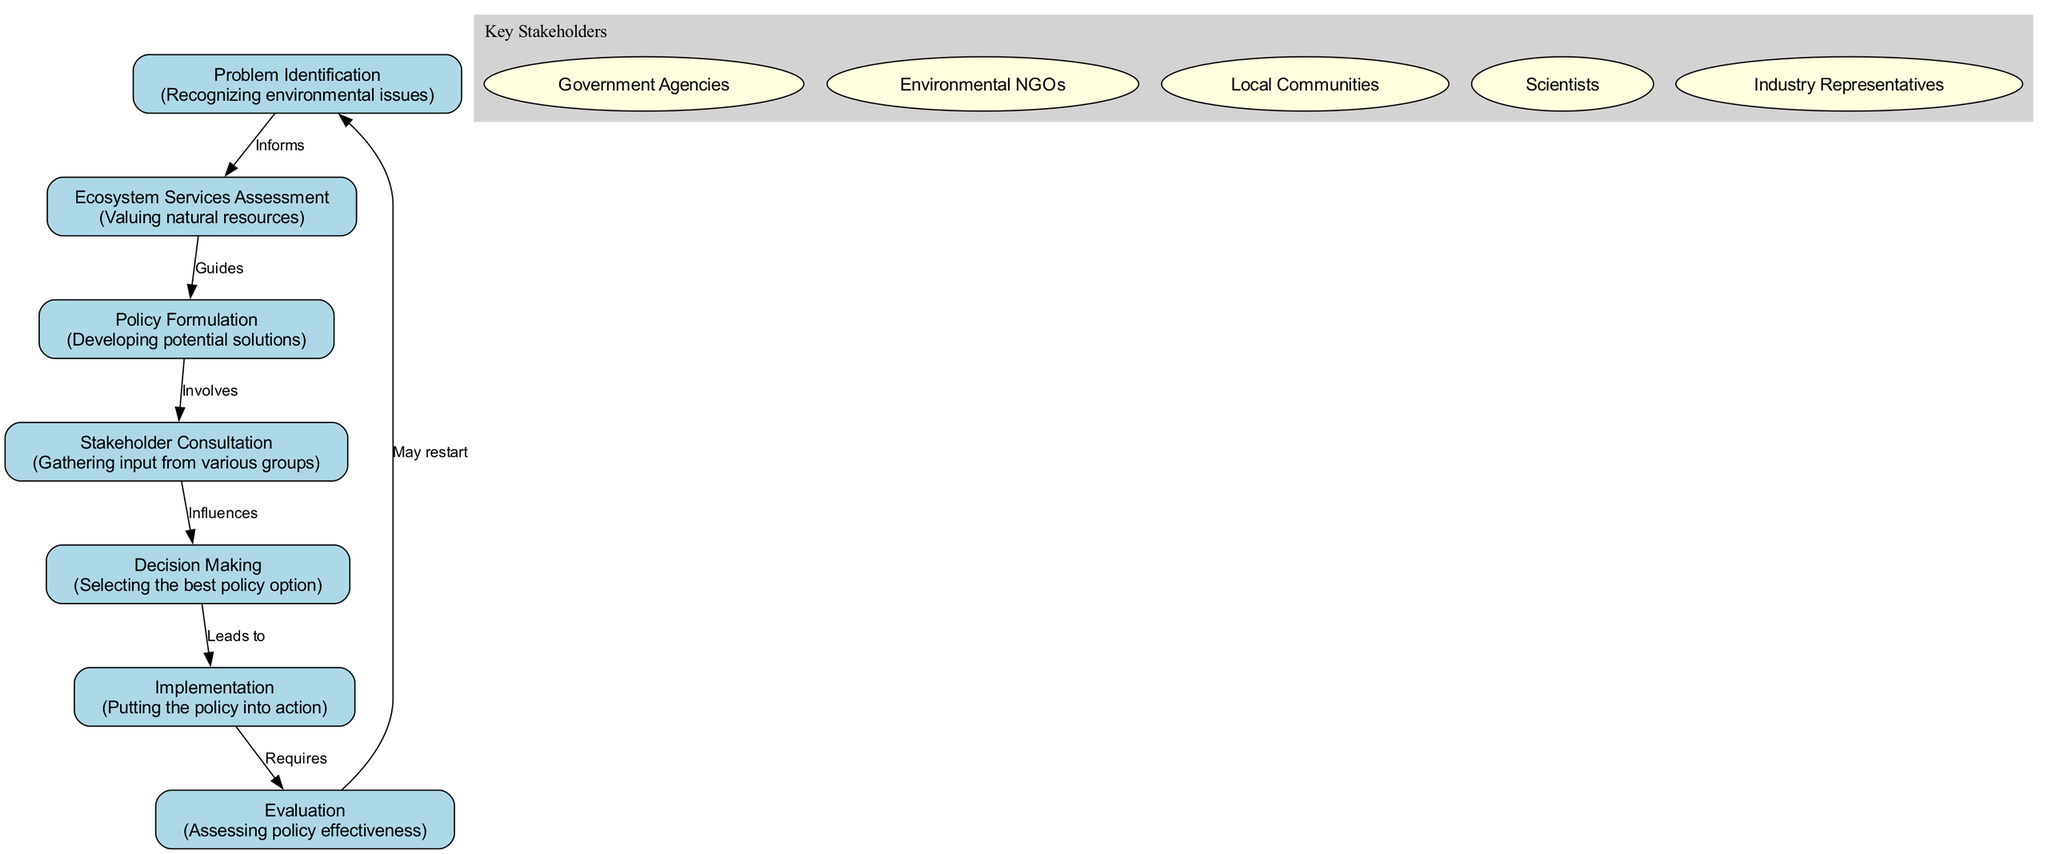What is the first step in the policy-making process? The diagram shows "Problem Identification" as the first node, indicating that recognizing environmental issues is the initial step in the policy-making process.
Answer: Problem Identification How many nodes are there in the diagram? By counting each distinct step in the policy-making process represented by a node, we identify a total of 7 nodes: Problem Identification, Ecosystem Services Assessment, Policy Formulation, Stakeholder Consultation, Decision Making, Implementation, and Evaluation.
Answer: 7 What does "Ecosystem Services Assessment" inform? Referring to the arrow labeled "Informs," the diagram indicates that "Problem Identification" informs "Ecosystem Services Assessment." Thus, identifying problems leads to the valuation of ecosystem services.
Answer: Problem Identification Which step involves gathering input from various groups? The diagram directly labels the third node as "Stakeholder Consultation," which explicitly states that this step is about gathering input from diverse stakeholders.
Answer: Stakeholder Consultation What step comes after "Decision Making"? Looking at the edges in the diagram, we notice that "Decision Making" is followed by "Implementation," indicating that the chosen policy is then put into action.
Answer: Implementation What is the relationship between "Evaluation" and "Problem Identification"? The diagram illustrates that "Evaluation," as the final step, has a potentially cycling relationship back to "Problem Identification," suggesting that evaluating policy effectiveness may highlight new problems to be addressed.
Answer: May restart Which stakeholders are involved in the policy-making process? The stakeholders listed in the cluster of the diagram include Government Agencies, Environmental NGOs, Local Communities, Scientists, and Industry Representatives.
Answer: Government Agencies, Environmental NGOs, Local Communities, Scientists, Industry Representatives Which node is influenced by stakeholder consultation? The diagram shows that "Stakeholder Consultation" influences the next step labeled as "Decision Making," indicating that stakeholders' input impacts the choice of policy options.
Answer: Decision Making What does the arrow labeled "Leads to" indicate? This arrow connects "Decision Making" to "Implementation," indicating that the selected policy option directly leads to its execution in the field.
Answer: Implementation 